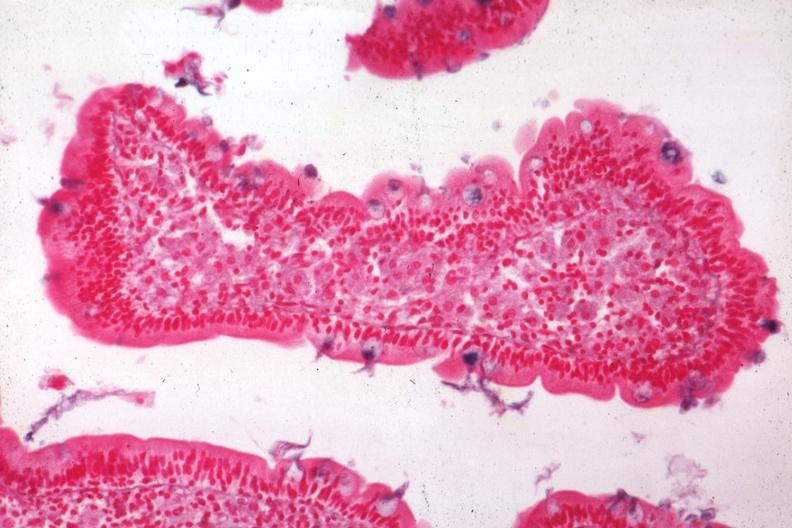s gastrointestinal present?
Answer the question using a single word or phrase. Yes 